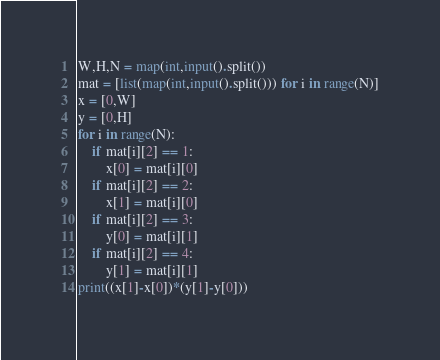<code> <loc_0><loc_0><loc_500><loc_500><_Python_>W,H,N = map(int,input().split())
mat = [list(map(int,input().split())) for i in range(N)]
x = [0,W]
y = [0,H]
for i in range(N):
    if mat[i][2] == 1:
        x[0] = mat[i][0]
    if mat[i][2] == 2:
        x[1] = mat[i][0]
    if mat[i][2] == 3:
        y[0] = mat[i][1]
    if mat[i][2] == 4:
        y[1] = mat[i][1]
print((x[1]-x[0])*(y[1]-y[0]))</code> 